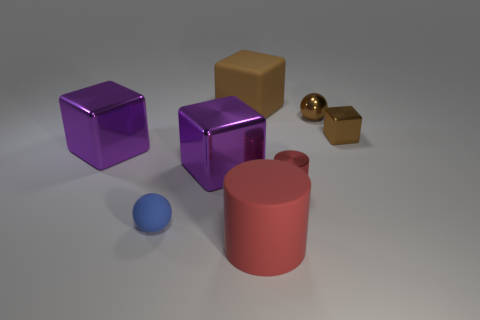Subtract all large brown rubber cubes. How many cubes are left? 3 Add 1 brown rubber objects. How many objects exist? 9 Subtract 1 cylinders. How many cylinders are left? 1 Subtract all cyan matte cylinders. Subtract all small blue things. How many objects are left? 7 Add 1 big purple shiny objects. How many big purple shiny objects are left? 3 Add 4 small brown objects. How many small brown objects exist? 6 Subtract all brown blocks. How many blocks are left? 2 Subtract 0 purple cylinders. How many objects are left? 8 Subtract all purple balls. Subtract all yellow cylinders. How many balls are left? 2 Subtract all blue cylinders. How many purple cubes are left? 2 